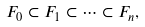Convert formula to latex. <formula><loc_0><loc_0><loc_500><loc_500>F _ { 0 } \subset F _ { 1 } \subset \dots \subset F _ { n } ,</formula> 